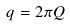<formula> <loc_0><loc_0><loc_500><loc_500>q = 2 \pi Q</formula> 